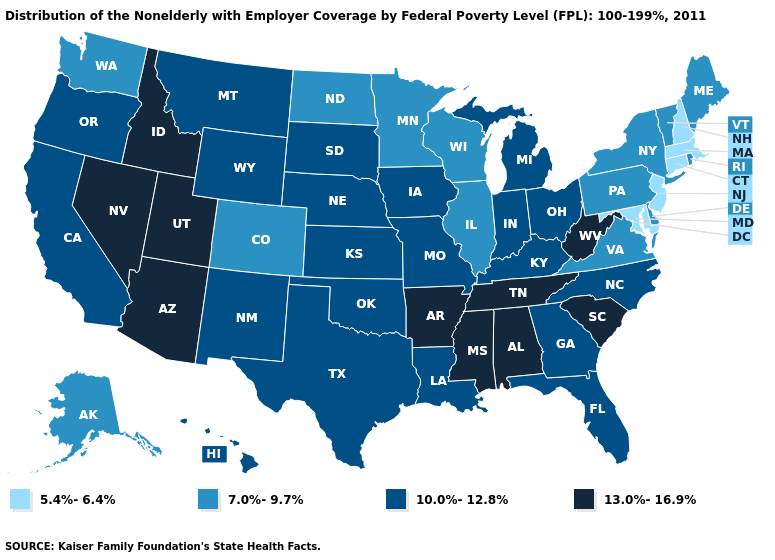Does the first symbol in the legend represent the smallest category?
Give a very brief answer. Yes. What is the value of Virginia?
Short answer required. 7.0%-9.7%. Name the states that have a value in the range 7.0%-9.7%?
Write a very short answer. Alaska, Colorado, Delaware, Illinois, Maine, Minnesota, New York, North Dakota, Pennsylvania, Rhode Island, Vermont, Virginia, Washington, Wisconsin. Does North Dakota have a higher value than Idaho?
Short answer required. No. Does Maine have the lowest value in the Northeast?
Concise answer only. No. Which states hav the highest value in the Northeast?
Write a very short answer. Maine, New York, Pennsylvania, Rhode Island, Vermont. Which states have the highest value in the USA?
Be succinct. Alabama, Arizona, Arkansas, Idaho, Mississippi, Nevada, South Carolina, Tennessee, Utah, West Virginia. Which states have the lowest value in the USA?
Quick response, please. Connecticut, Maryland, Massachusetts, New Hampshire, New Jersey. Among the states that border Wisconsin , which have the lowest value?
Be succinct. Illinois, Minnesota. Name the states that have a value in the range 10.0%-12.8%?
Keep it brief. California, Florida, Georgia, Hawaii, Indiana, Iowa, Kansas, Kentucky, Louisiana, Michigan, Missouri, Montana, Nebraska, New Mexico, North Carolina, Ohio, Oklahoma, Oregon, South Dakota, Texas, Wyoming. What is the value of North Dakota?
Be succinct. 7.0%-9.7%. Among the states that border Maine , which have the highest value?
Concise answer only. New Hampshire. Which states hav the highest value in the MidWest?
Answer briefly. Indiana, Iowa, Kansas, Michigan, Missouri, Nebraska, Ohio, South Dakota. What is the value of Kansas?
Short answer required. 10.0%-12.8%. Name the states that have a value in the range 7.0%-9.7%?
Keep it brief. Alaska, Colorado, Delaware, Illinois, Maine, Minnesota, New York, North Dakota, Pennsylvania, Rhode Island, Vermont, Virginia, Washington, Wisconsin. 